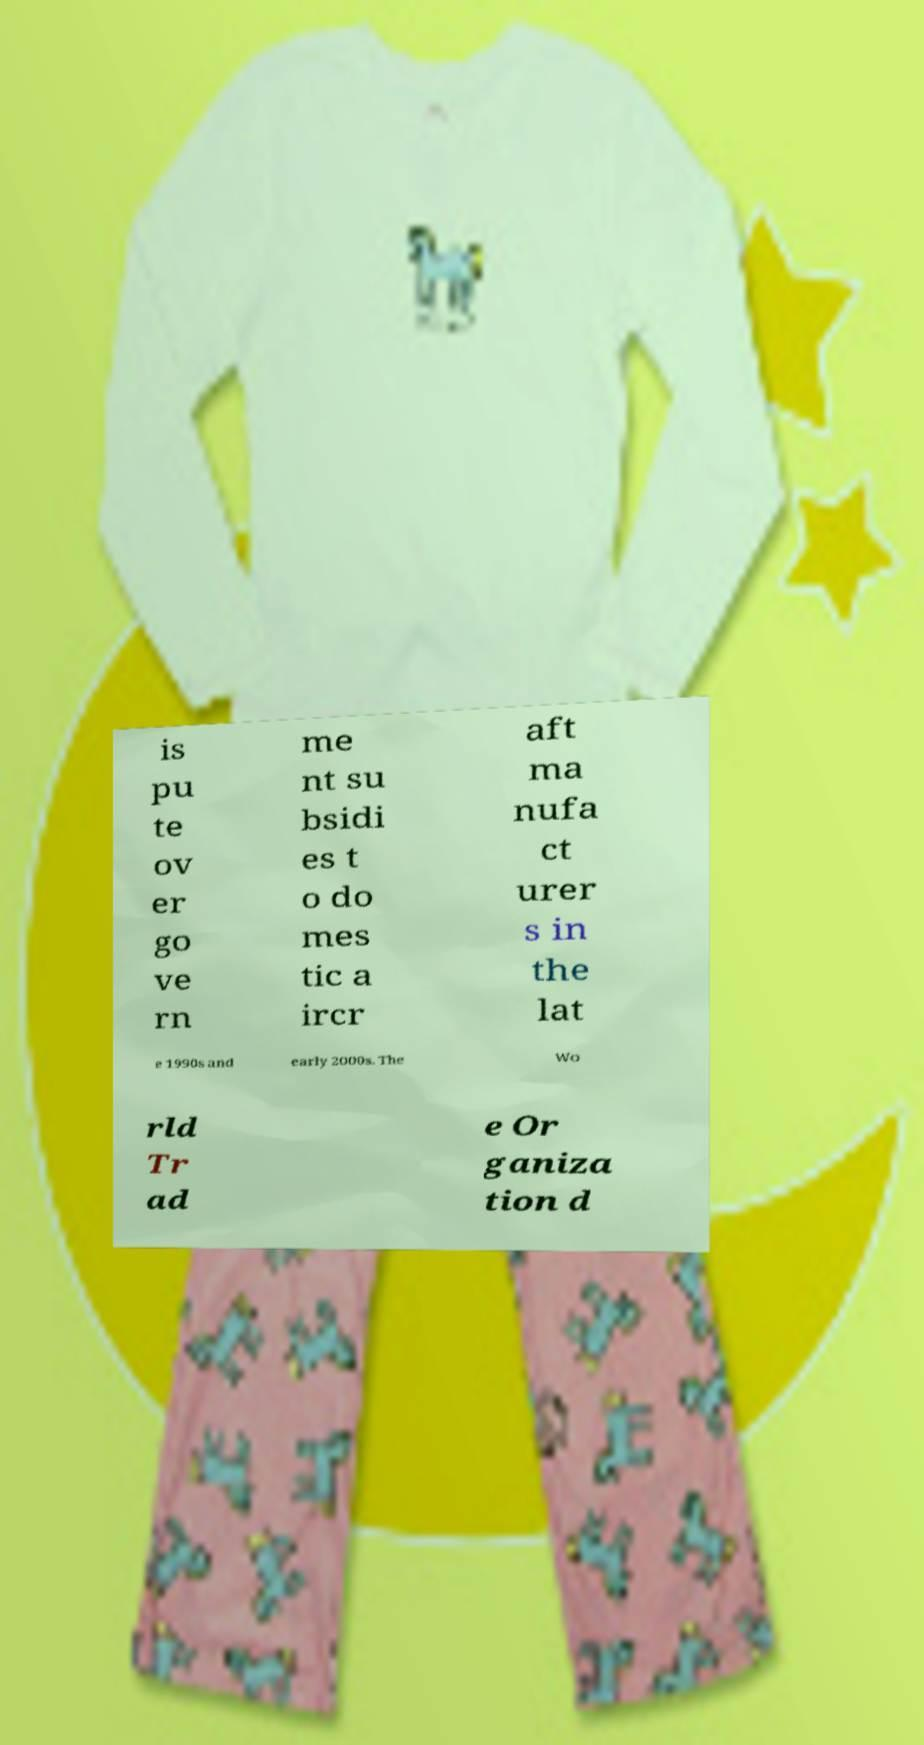Please read and relay the text visible in this image. What does it say? is pu te ov er go ve rn me nt su bsidi es t o do mes tic a ircr aft ma nufa ct urer s in the lat e 1990s and early 2000s. The Wo rld Tr ad e Or ganiza tion d 